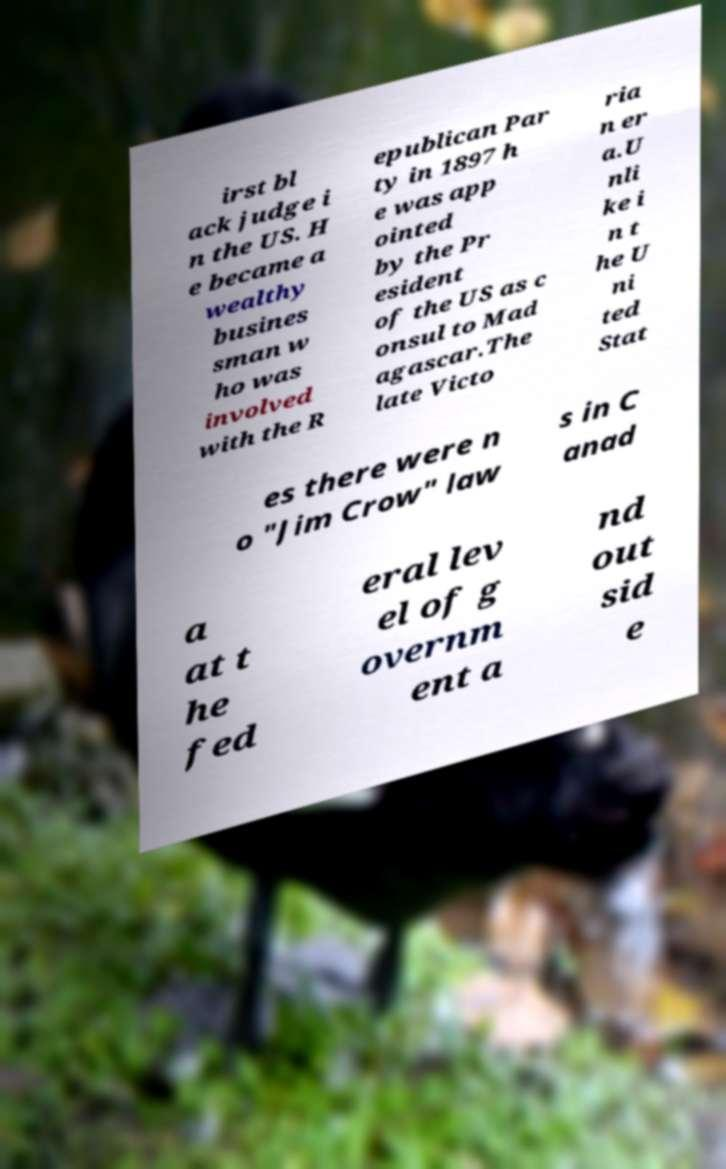Please identify and transcribe the text found in this image. irst bl ack judge i n the US. H e became a wealthy busines sman w ho was involved with the R epublican Par ty in 1897 h e was app ointed by the Pr esident of the US as c onsul to Mad agascar.The late Victo ria n er a.U nli ke i n t he U ni ted Stat es there were n o "Jim Crow" law s in C anad a at t he fed eral lev el of g overnm ent a nd out sid e 